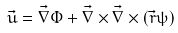Convert formula to latex. <formula><loc_0><loc_0><loc_500><loc_500>\vec { u } = \vec { \nabla } \Phi + \vec { \nabla } \times \vec { \nabla } \times ( \vec { r } \psi )</formula> 